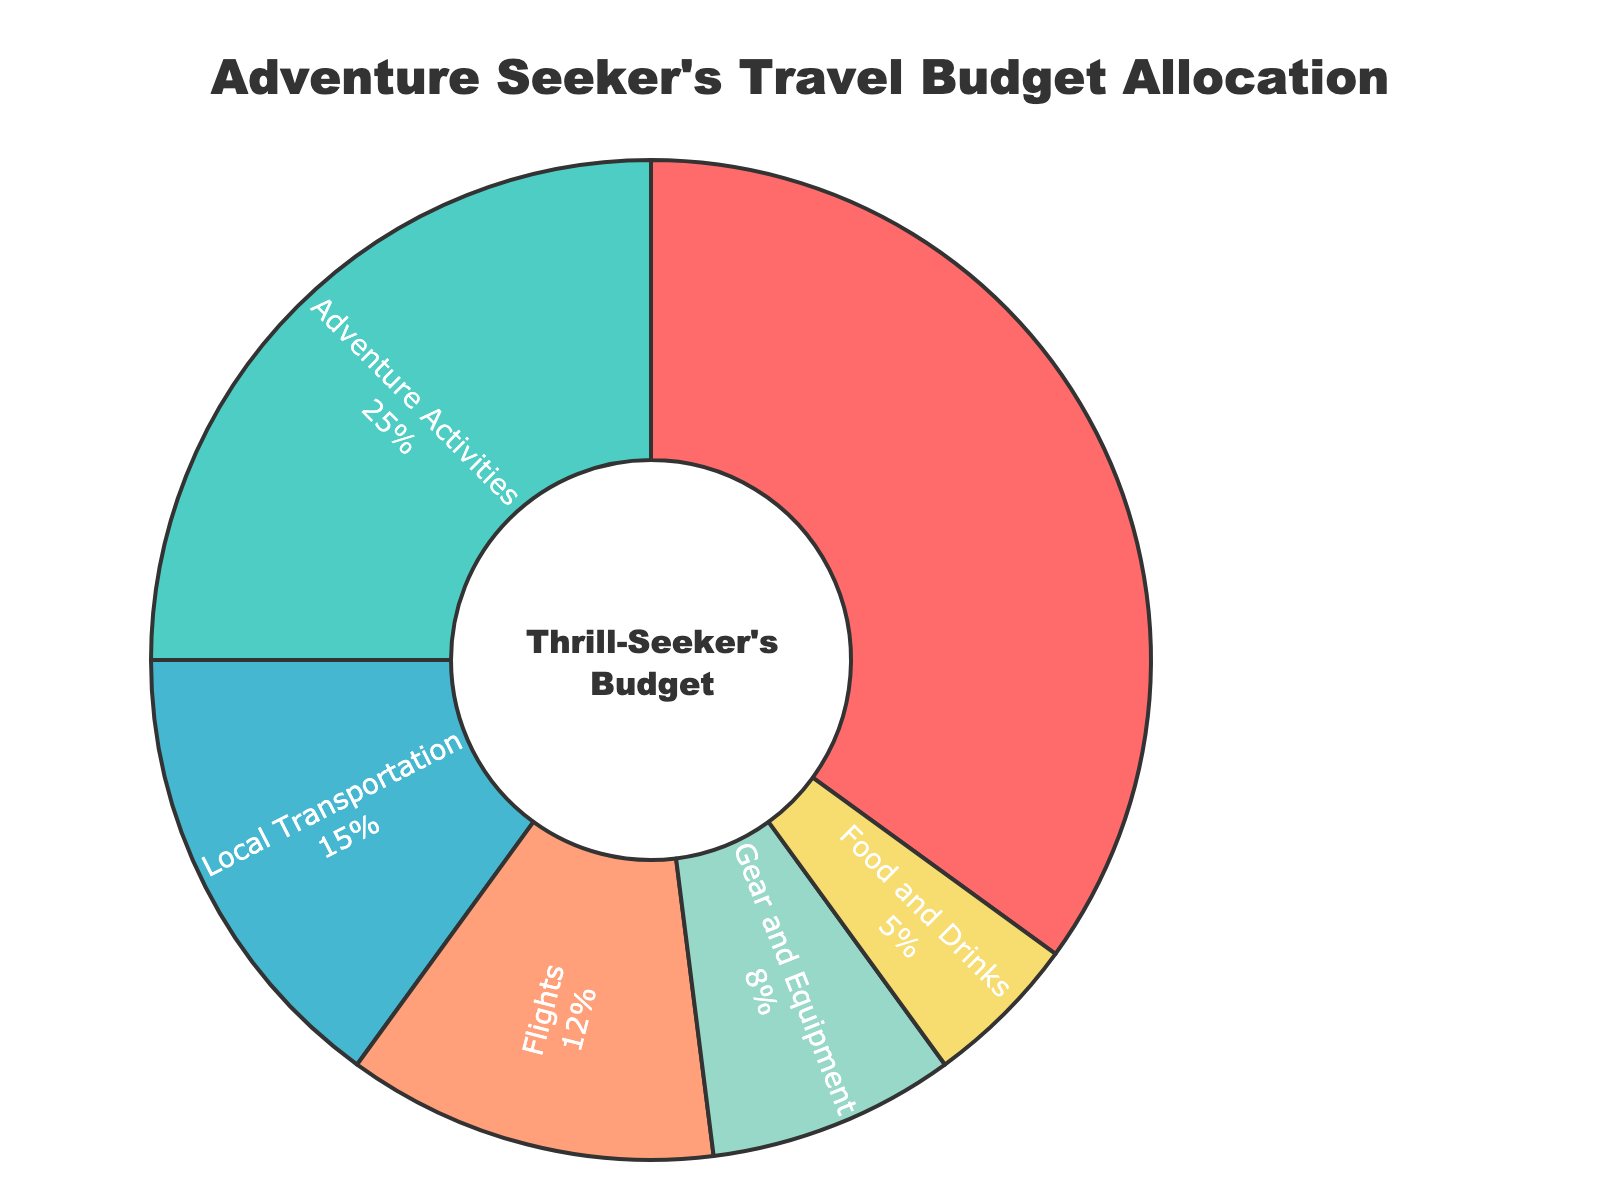What is the largest category in the adventure seeker's travel budget allocation? The pie chart shows that the "Unique Accommodations" category has the largest slice, indicating it takes up the highest percentage.
Answer: Unique Accommodations How much more is allocated to unique accommodations compared to local transportation? The percentage for unique accommodations is 35%, and for local transportation, it is 15%. The difference is calculated as 35% - 15% = 20%.
Answer: 20% What is the total percentage allocated to flights and food and drinks combined? The percentage allocated to flights is 12%, and for food and drinks, it is 5%. Summing these up: 12% + 5% = 17%.
Answer: 17% Which category gets less allocation, gear and equipment or local transportation? The pie chart shows that gear and equipment have an 8% allocation, whereas local transportation has a 15% allocation. Therefore, gear and equipment receive less allocation.
Answer: Gear and Equipment Is the sum of the percentages for adventure activities and local transportation equal to more than half the budget? The pie chart shows that adventure activities receive 25% and local transportation 15%. Adding these two: 25% + 15% = 40%, which is less than half the budget.
Answer: No What is the combined percentage allocation for unique accommodations and adventure activities? Unique accommodations have a 35% allocation, and adventure activities have 25%. Combined, they sum up to 35% + 25% = 60%.
Answer: 60% If we combine the percentages for adventure activities, local transportation, and food and drinks, would they sum up to more or less than unique accommodations? Adventure activities: 25%, local transportation: 15%, and food and drinks: 5%. Summing these: 25% + 15% + 5% = 45%. Since 45% is more than the 35% allocation for unique accommodations, they sum up to more.
Answer: More Which category occupies the smallest slice of the pie chart? By visually inspecting the pie chart, the "Food and Drinks" category appears to have the smallest slice, indicating the lowest percentage allocation.
Answer: Food and Drinks How many categories have an allocation of at least 15%? The categories with at least 15% allocation are unique accommodations (35%), adventure activities (25%), and local transportation (15%). There are three categories in total.
Answer: Three Which is greater, the combined percentage of gear and equipment and food and drinks, or the percentage for adventure activities? Gear and equipment have an 8% allocation, and food and drinks have 5%. Their combined percentage is 8% + 5% = 13%. The percentage for adventure activities is 25%, which is greater than 13%.
Answer: Adventure Activities 